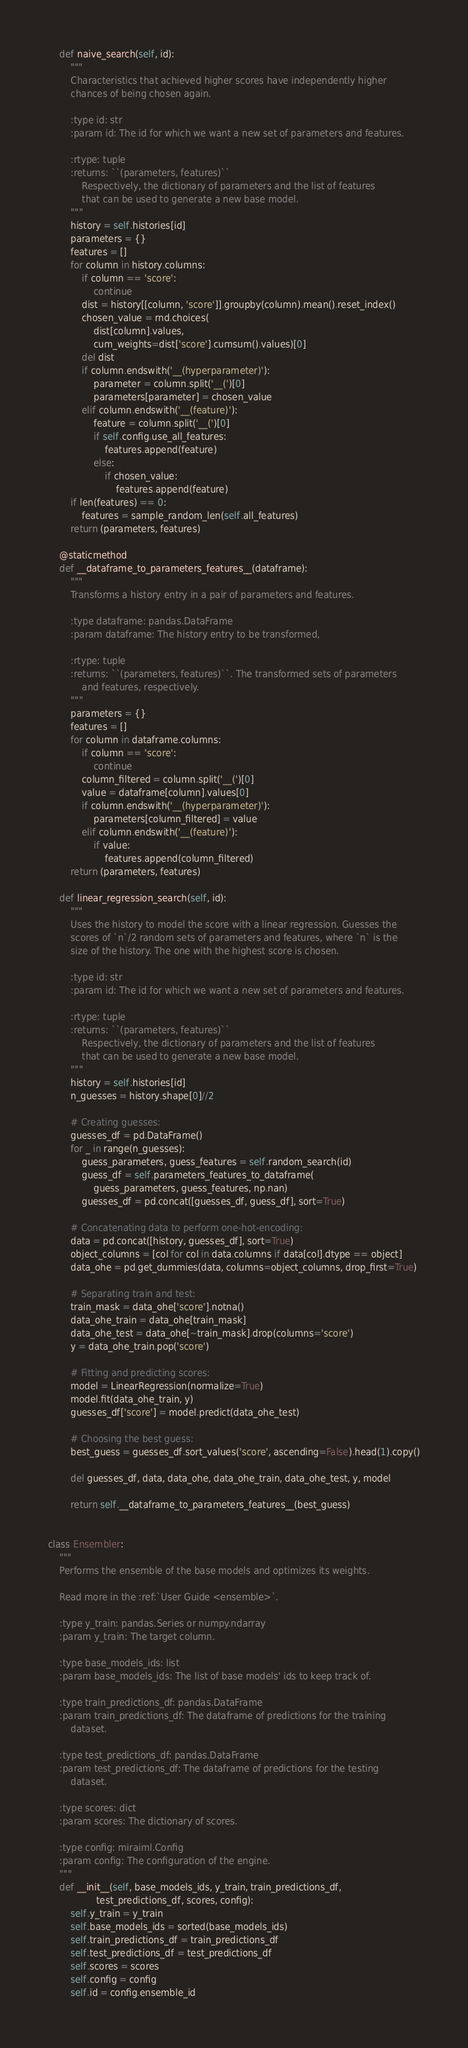Convert code to text. <code><loc_0><loc_0><loc_500><loc_500><_Python_>    def naive_search(self, id):
        """
        Characteristics that achieved higher scores have independently higher
        chances of being chosen again.

        :type id: str
        :param id: The id for which we want a new set of parameters and features.

        :rtype: tuple
        :returns: ``(parameters, features)``
            Respectively, the dictionary of parameters and the list of features
            that can be used to generate a new base model.
        """
        history = self.histories[id]
        parameters = {}
        features = []
        for column in history.columns:
            if column == 'score':
                continue
            dist = history[[column, 'score']].groupby(column).mean().reset_index()
            chosen_value = rnd.choices(
                dist[column].values,
                cum_weights=dist['score'].cumsum().values)[0]
            del dist
            if column.endswith('__(hyperparameter)'):
                parameter = column.split('__(')[0]
                parameters[parameter] = chosen_value
            elif column.endswith('__(feature)'):
                feature = column.split('__(')[0]
                if self.config.use_all_features:
                    features.append(feature)
                else:
                    if chosen_value:
                        features.append(feature)
        if len(features) == 0:
            features = sample_random_len(self.all_features)
        return (parameters, features)

    @staticmethod
    def __dataframe_to_parameters_features__(dataframe):
        """
        Transforms a history entry in a pair of parameters and features.

        :type dataframe: pandas.DataFrame
        :param dataframe: The history entry to be transformed,

        :rtype: tuple
        :returns: ``(parameters, features)``. The transformed sets of parameters
            and features, respectively.
        """
        parameters = {}
        features = []
        for column in dataframe.columns:
            if column == 'score':
                continue
            column_filtered = column.split('__(')[0]
            value = dataframe[column].values[0]
            if column.endswith('__(hyperparameter)'):
                parameters[column_filtered] = value
            elif column.endswith('__(feature)'):
                if value:
                    features.append(column_filtered)
        return (parameters, features)

    def linear_regression_search(self, id):
        """
        Uses the history to model the score with a linear regression. Guesses the
        scores of `n`/2 random sets of parameters and features, where `n` is the
        size of the history. The one with the highest score is chosen.

        :type id: str
        :param id: The id for which we want a new set of parameters and features.

        :rtype: tuple
        :returns: ``(parameters, features)``
            Respectively, the dictionary of parameters and the list of features
            that can be used to generate a new base model.
        """
        history = self.histories[id]
        n_guesses = history.shape[0]//2

        # Creating guesses:
        guesses_df = pd.DataFrame()
        for _ in range(n_guesses):
            guess_parameters, guess_features = self.random_search(id)
            guess_df = self.parameters_features_to_dataframe(
                guess_parameters, guess_features, np.nan)
            guesses_df = pd.concat([guesses_df, guess_df], sort=True)

        # Concatenating data to perform one-hot-encoding:
        data = pd.concat([history, guesses_df], sort=True)
        object_columns = [col for col in data.columns if data[col].dtype == object]
        data_ohe = pd.get_dummies(data, columns=object_columns, drop_first=True)

        # Separating train and test:
        train_mask = data_ohe['score'].notna()
        data_ohe_train = data_ohe[train_mask]
        data_ohe_test = data_ohe[~train_mask].drop(columns='score')
        y = data_ohe_train.pop('score')

        # Fitting and predicting scores:
        model = LinearRegression(normalize=True)
        model.fit(data_ohe_train, y)
        guesses_df['score'] = model.predict(data_ohe_test)

        # Choosing the best guess:
        best_guess = guesses_df.sort_values('score', ascending=False).head(1).copy()

        del guesses_df, data, data_ohe, data_ohe_train, data_ohe_test, y, model

        return self.__dataframe_to_parameters_features__(best_guess)


class Ensembler:
    """
    Performs the ensemble of the base models and optimizes its weights.

    Read more in the :ref:`User Guide <ensemble>`.

    :type y_train: pandas.Series or numpy.ndarray
    :param y_train: The target column.

    :type base_models_ids: list
    :param base_models_ids: The list of base models' ids to keep track of.

    :type train_predictions_df: pandas.DataFrame
    :param train_predictions_df: The dataframe of predictions for the training
        dataset.

    :type test_predictions_df: pandas.DataFrame
    :param test_predictions_df: The dataframe of predictions for the testing
        dataset.

    :type scores: dict
    :param scores: The dictionary of scores.

    :type config: miraiml.Config
    :param config: The configuration of the engine.
    """
    def __init__(self, base_models_ids, y_train, train_predictions_df,
                 test_predictions_df, scores, config):
        self.y_train = y_train
        self.base_models_ids = sorted(base_models_ids)
        self.train_predictions_df = train_predictions_df
        self.test_predictions_df = test_predictions_df
        self.scores = scores
        self.config = config
        self.id = config.ensemble_id</code> 